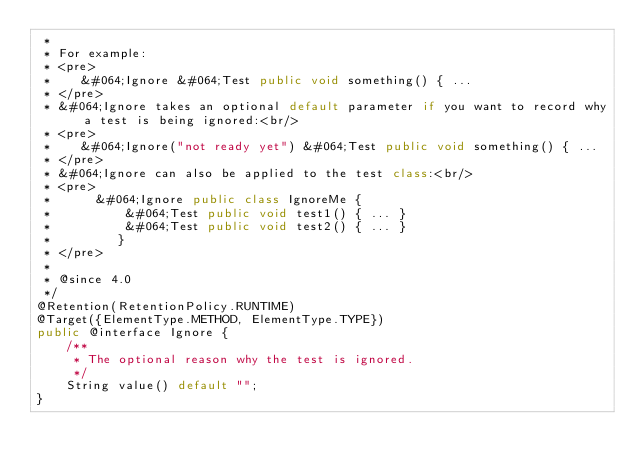<code> <loc_0><loc_0><loc_500><loc_500><_Java_> *
 * For example:
 * <pre>
 *    &#064;Ignore &#064;Test public void something() { ...
 * </pre>
 * &#064;Ignore takes an optional default parameter if you want to record why a test is being ignored:<br/>
 * <pre>
 *    &#064;Ignore("not ready yet") &#064;Test public void something() { ...
 * </pre>
 * &#064;Ignore can also be applied to the test class:<br/>
 * <pre>
 *      &#064;Ignore public class IgnoreMe {
 *          &#064;Test public void test1() { ... }
 *          &#064;Test public void test2() { ... }
 *         }
 * </pre>
 *
 * @since 4.0
 */
@Retention(RetentionPolicy.RUNTIME)
@Target({ElementType.METHOD, ElementType.TYPE})
public @interface Ignore {
    /**
     * The optional reason why the test is ignored.
     */
    String value() default "";
}
</code> 